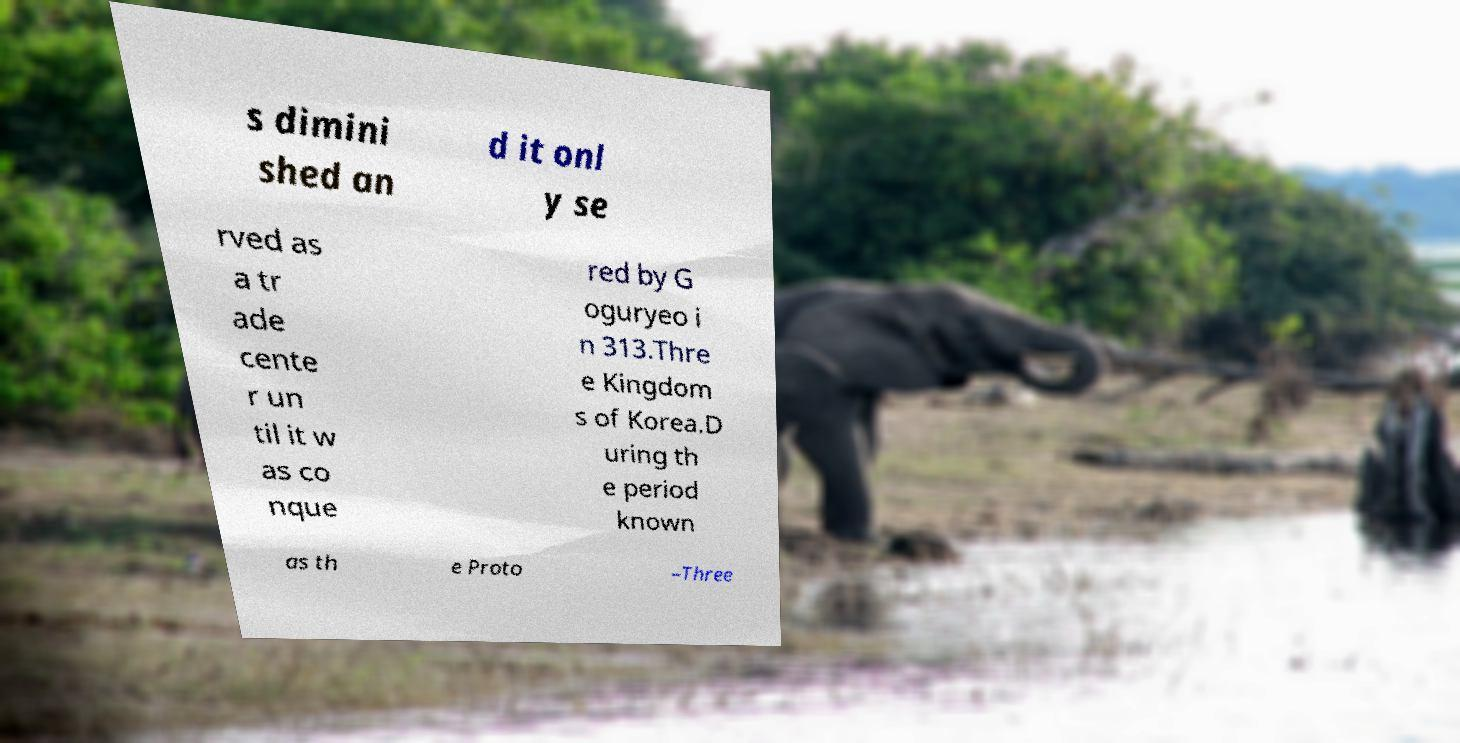Could you assist in decoding the text presented in this image and type it out clearly? s dimini shed an d it onl y se rved as a tr ade cente r un til it w as co nque red by G oguryeo i n 313.Thre e Kingdom s of Korea.D uring th e period known as th e Proto –Three 